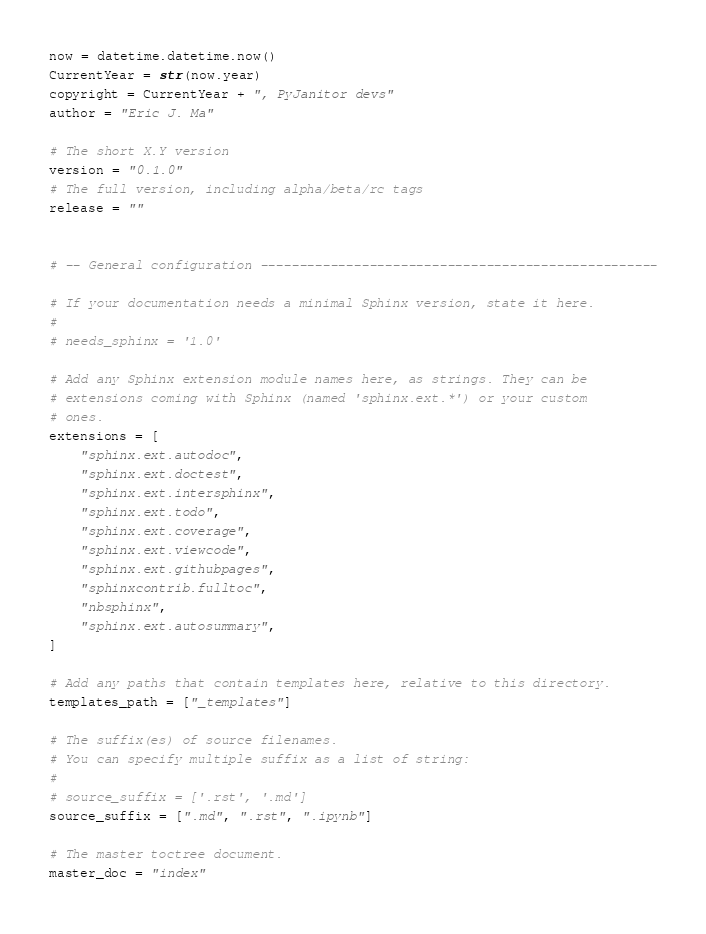<code> <loc_0><loc_0><loc_500><loc_500><_Python_>
now = datetime.datetime.now()
CurrentYear = str(now.year)
copyright = CurrentYear + ", PyJanitor devs"
author = "Eric J. Ma"

# The short X.Y version
version = "0.1.0"
# The full version, including alpha/beta/rc tags
release = ""


# -- General configuration ---------------------------------------------------

# If your documentation needs a minimal Sphinx version, state it here.
#
# needs_sphinx = '1.0'

# Add any Sphinx extension module names here, as strings. They can be
# extensions coming with Sphinx (named 'sphinx.ext.*') or your custom
# ones.
extensions = [
    "sphinx.ext.autodoc",
    "sphinx.ext.doctest",
    "sphinx.ext.intersphinx",
    "sphinx.ext.todo",
    "sphinx.ext.coverage",
    "sphinx.ext.viewcode",
    "sphinx.ext.githubpages",
    "sphinxcontrib.fulltoc",
    "nbsphinx",
    "sphinx.ext.autosummary",
]

# Add any paths that contain templates here, relative to this directory.
templates_path = ["_templates"]

# The suffix(es) of source filenames.
# You can specify multiple suffix as a list of string:
#
# source_suffix = ['.rst', '.md']
source_suffix = [".md", ".rst", ".ipynb"]

# The master toctree document.
master_doc = "index"
</code> 